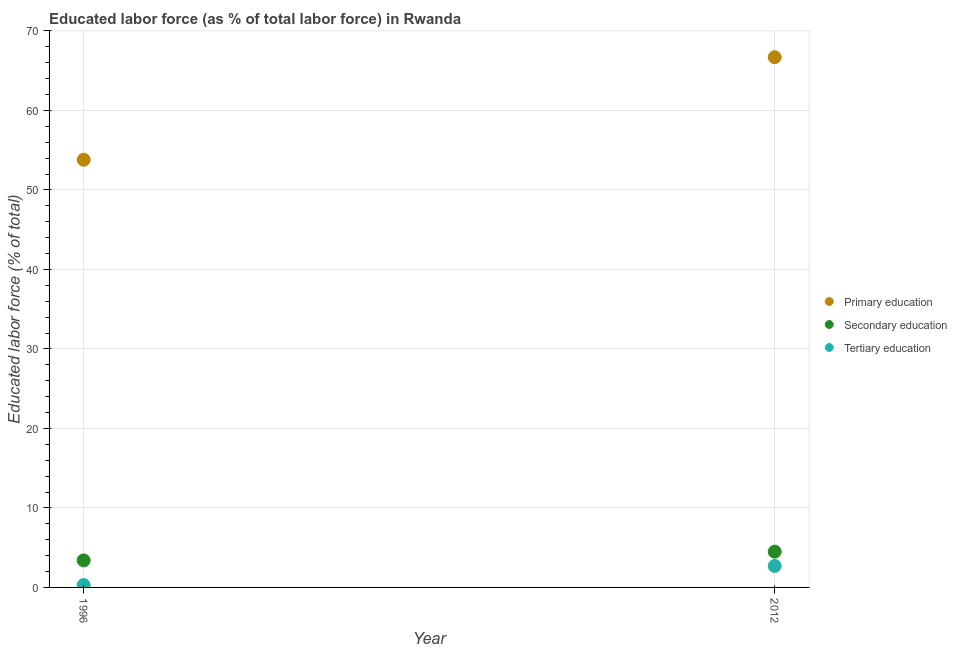How many different coloured dotlines are there?
Ensure brevity in your answer.  3. What is the percentage of labor force who received tertiary education in 1996?
Offer a very short reply. 0.3. Across all years, what is the maximum percentage of labor force who received tertiary education?
Ensure brevity in your answer.  2.7. Across all years, what is the minimum percentage of labor force who received primary education?
Ensure brevity in your answer.  53.8. In which year was the percentage of labor force who received tertiary education minimum?
Provide a short and direct response. 1996. What is the total percentage of labor force who received secondary education in the graph?
Your answer should be very brief. 7.9. What is the difference between the percentage of labor force who received primary education in 1996 and that in 2012?
Your answer should be very brief. -12.9. What is the difference between the percentage of labor force who received secondary education in 2012 and the percentage of labor force who received tertiary education in 1996?
Your answer should be very brief. 4.2. What is the average percentage of labor force who received secondary education per year?
Give a very brief answer. 3.95. In the year 1996, what is the difference between the percentage of labor force who received secondary education and percentage of labor force who received primary education?
Keep it short and to the point. -50.4. In how many years, is the percentage of labor force who received tertiary education greater than 28 %?
Offer a very short reply. 0. What is the ratio of the percentage of labor force who received tertiary education in 1996 to that in 2012?
Provide a short and direct response. 0.11. In how many years, is the percentage of labor force who received primary education greater than the average percentage of labor force who received primary education taken over all years?
Your answer should be very brief. 1. Does the percentage of labor force who received primary education monotonically increase over the years?
Offer a terse response. Yes. Are the values on the major ticks of Y-axis written in scientific E-notation?
Your answer should be very brief. No. Does the graph contain grids?
Keep it short and to the point. Yes. Where does the legend appear in the graph?
Keep it short and to the point. Center right. What is the title of the graph?
Offer a terse response. Educated labor force (as % of total labor force) in Rwanda. What is the label or title of the Y-axis?
Offer a terse response. Educated labor force (% of total). What is the Educated labor force (% of total) of Primary education in 1996?
Offer a very short reply. 53.8. What is the Educated labor force (% of total) of Secondary education in 1996?
Give a very brief answer. 3.4. What is the Educated labor force (% of total) in Tertiary education in 1996?
Your response must be concise. 0.3. What is the Educated labor force (% of total) of Primary education in 2012?
Keep it short and to the point. 66.7. What is the Educated labor force (% of total) of Tertiary education in 2012?
Keep it short and to the point. 2.7. Across all years, what is the maximum Educated labor force (% of total) in Primary education?
Offer a very short reply. 66.7. Across all years, what is the maximum Educated labor force (% of total) in Secondary education?
Keep it short and to the point. 4.5. Across all years, what is the maximum Educated labor force (% of total) in Tertiary education?
Your answer should be compact. 2.7. Across all years, what is the minimum Educated labor force (% of total) of Primary education?
Give a very brief answer. 53.8. Across all years, what is the minimum Educated labor force (% of total) in Secondary education?
Ensure brevity in your answer.  3.4. Across all years, what is the minimum Educated labor force (% of total) in Tertiary education?
Ensure brevity in your answer.  0.3. What is the total Educated labor force (% of total) in Primary education in the graph?
Your response must be concise. 120.5. What is the total Educated labor force (% of total) of Secondary education in the graph?
Offer a terse response. 7.9. What is the difference between the Educated labor force (% of total) of Primary education in 1996 and that in 2012?
Your response must be concise. -12.9. What is the difference between the Educated labor force (% of total) of Secondary education in 1996 and that in 2012?
Provide a succinct answer. -1.1. What is the difference between the Educated labor force (% of total) of Tertiary education in 1996 and that in 2012?
Your answer should be very brief. -2.4. What is the difference between the Educated labor force (% of total) in Primary education in 1996 and the Educated labor force (% of total) in Secondary education in 2012?
Offer a very short reply. 49.3. What is the difference between the Educated labor force (% of total) of Primary education in 1996 and the Educated labor force (% of total) of Tertiary education in 2012?
Offer a very short reply. 51.1. What is the difference between the Educated labor force (% of total) of Secondary education in 1996 and the Educated labor force (% of total) of Tertiary education in 2012?
Your answer should be very brief. 0.7. What is the average Educated labor force (% of total) of Primary education per year?
Ensure brevity in your answer.  60.25. What is the average Educated labor force (% of total) in Secondary education per year?
Ensure brevity in your answer.  3.95. What is the average Educated labor force (% of total) of Tertiary education per year?
Provide a short and direct response. 1.5. In the year 1996, what is the difference between the Educated labor force (% of total) in Primary education and Educated labor force (% of total) in Secondary education?
Offer a terse response. 50.4. In the year 1996, what is the difference between the Educated labor force (% of total) in Primary education and Educated labor force (% of total) in Tertiary education?
Give a very brief answer. 53.5. In the year 1996, what is the difference between the Educated labor force (% of total) in Secondary education and Educated labor force (% of total) in Tertiary education?
Provide a short and direct response. 3.1. In the year 2012, what is the difference between the Educated labor force (% of total) in Primary education and Educated labor force (% of total) in Secondary education?
Offer a terse response. 62.2. In the year 2012, what is the difference between the Educated labor force (% of total) of Primary education and Educated labor force (% of total) of Tertiary education?
Provide a succinct answer. 64. What is the ratio of the Educated labor force (% of total) in Primary education in 1996 to that in 2012?
Make the answer very short. 0.81. What is the ratio of the Educated labor force (% of total) of Secondary education in 1996 to that in 2012?
Your response must be concise. 0.76. What is the ratio of the Educated labor force (% of total) of Tertiary education in 1996 to that in 2012?
Make the answer very short. 0.11. What is the difference between the highest and the second highest Educated labor force (% of total) in Primary education?
Keep it short and to the point. 12.9. What is the difference between the highest and the second highest Educated labor force (% of total) of Secondary education?
Give a very brief answer. 1.1. What is the difference between the highest and the lowest Educated labor force (% of total) of Primary education?
Your answer should be compact. 12.9. What is the difference between the highest and the lowest Educated labor force (% of total) of Secondary education?
Offer a terse response. 1.1. 